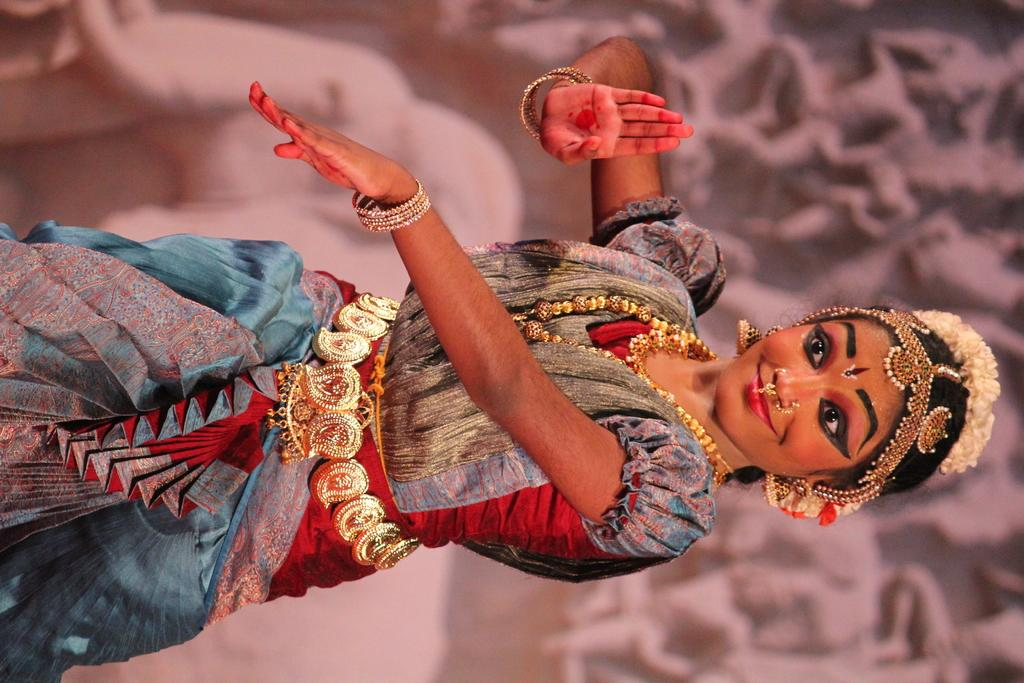Who is the main subject in the image? There is a girl in the image. What is the girl doing in the image? The girl is standing in the image. What is the girl wearing in the image? The girl is wearing a costume in the image. How much wealth does the girl's dad have in the image? There is no information about the girl's dad or their wealth in the image. 